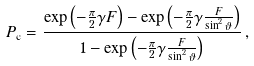Convert formula to latex. <formula><loc_0><loc_0><loc_500><loc_500>P _ { \text {c} } = \frac { \exp \left ( - \frac { \pi } { 2 } \gamma F \right ) - \exp \left ( - \frac { \pi } { 2 } \gamma \frac { F } { \sin ^ { 2 } \vartheta } \right ) } { 1 - \exp \left ( - \frac { \pi } { 2 } \gamma \frac { F } { \sin ^ { 2 } \vartheta } \right ) } \, ,</formula> 